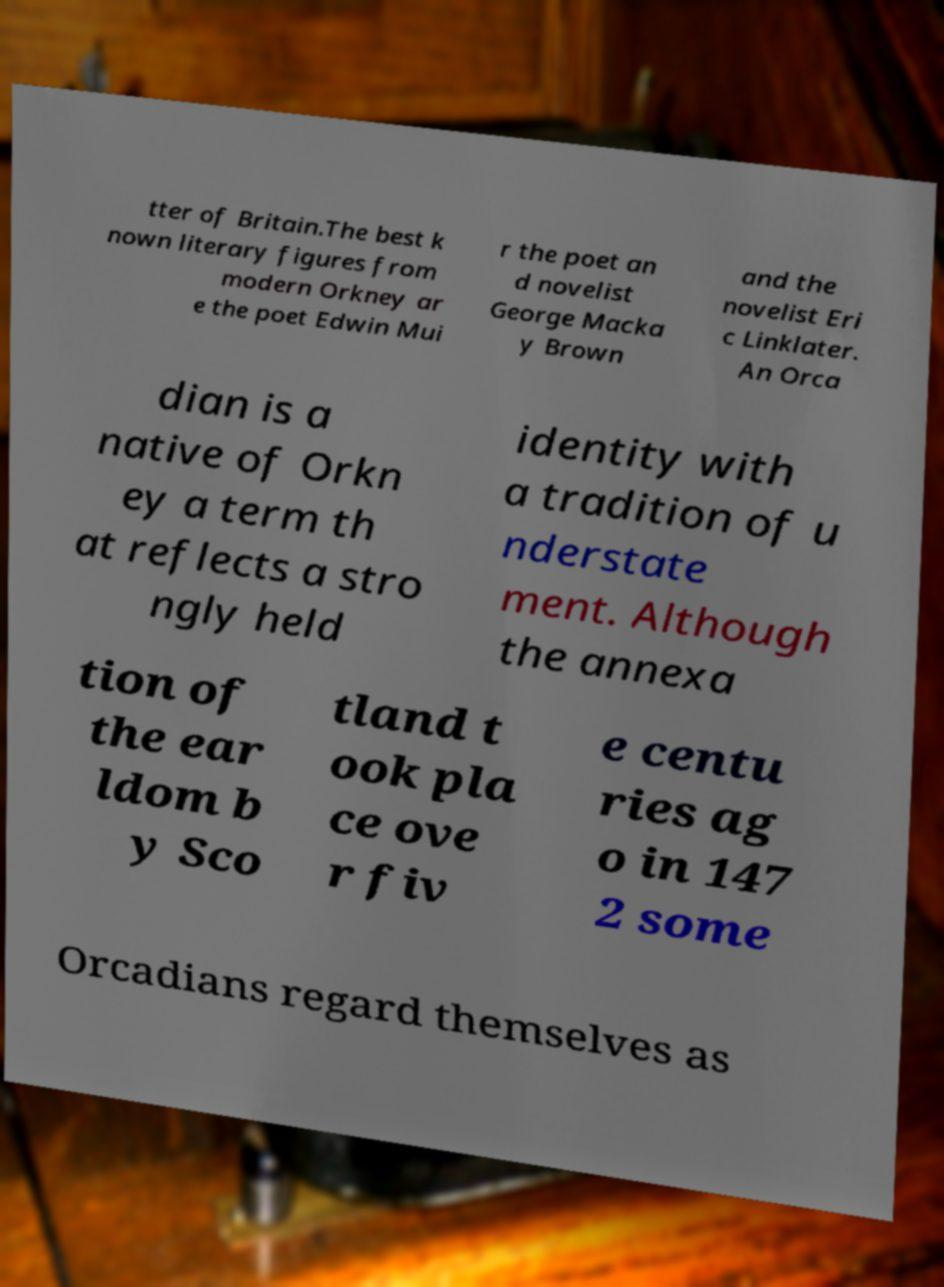Please read and relay the text visible in this image. What does it say? tter of Britain.The best k nown literary figures from modern Orkney ar e the poet Edwin Mui r the poet an d novelist George Macka y Brown and the novelist Eri c Linklater. An Orca dian is a native of Orkn ey a term th at reflects a stro ngly held identity with a tradition of u nderstate ment. Although the annexa tion of the ear ldom b y Sco tland t ook pla ce ove r fiv e centu ries ag o in 147 2 some Orcadians regard themselves as 